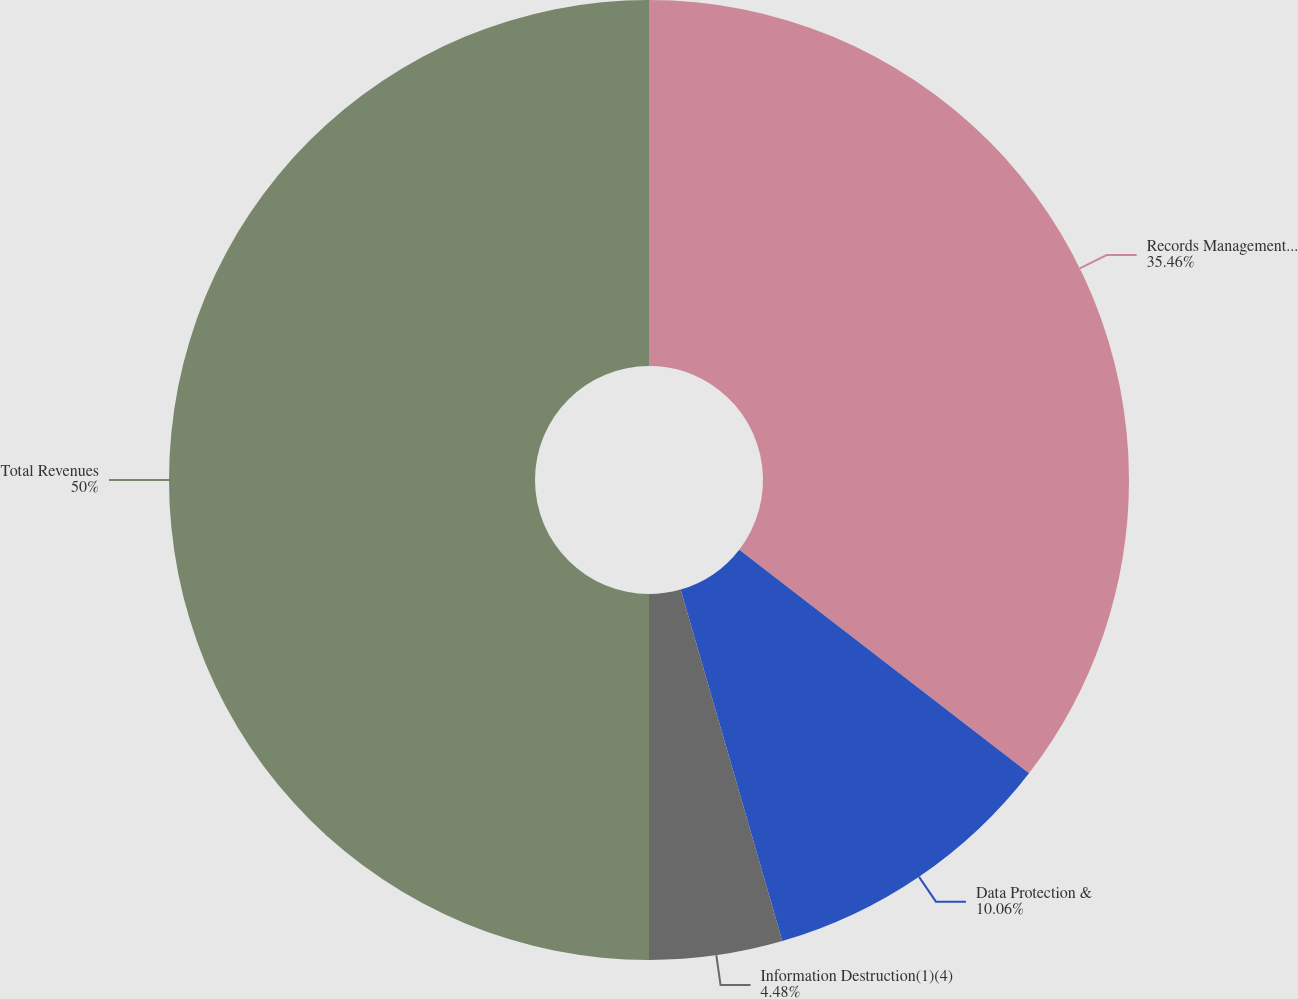Convert chart. <chart><loc_0><loc_0><loc_500><loc_500><pie_chart><fcel>Records Management(1)(2)<fcel>Data Protection &<fcel>Information Destruction(1)(4)<fcel>Total Revenues<nl><fcel>35.46%<fcel>10.06%<fcel>4.48%<fcel>50.0%<nl></chart> 